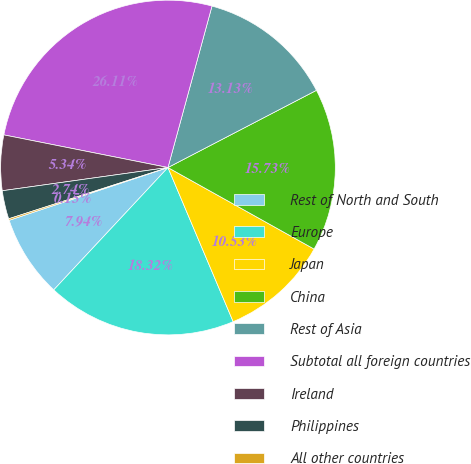<chart> <loc_0><loc_0><loc_500><loc_500><pie_chart><fcel>Rest of North and South<fcel>Europe<fcel>Japan<fcel>China<fcel>Rest of Asia<fcel>Subtotal all foreign countries<fcel>Ireland<fcel>Philippines<fcel>All other countries<nl><fcel>7.94%<fcel>18.32%<fcel>10.53%<fcel>15.73%<fcel>13.13%<fcel>26.11%<fcel>5.34%<fcel>2.74%<fcel>0.15%<nl></chart> 